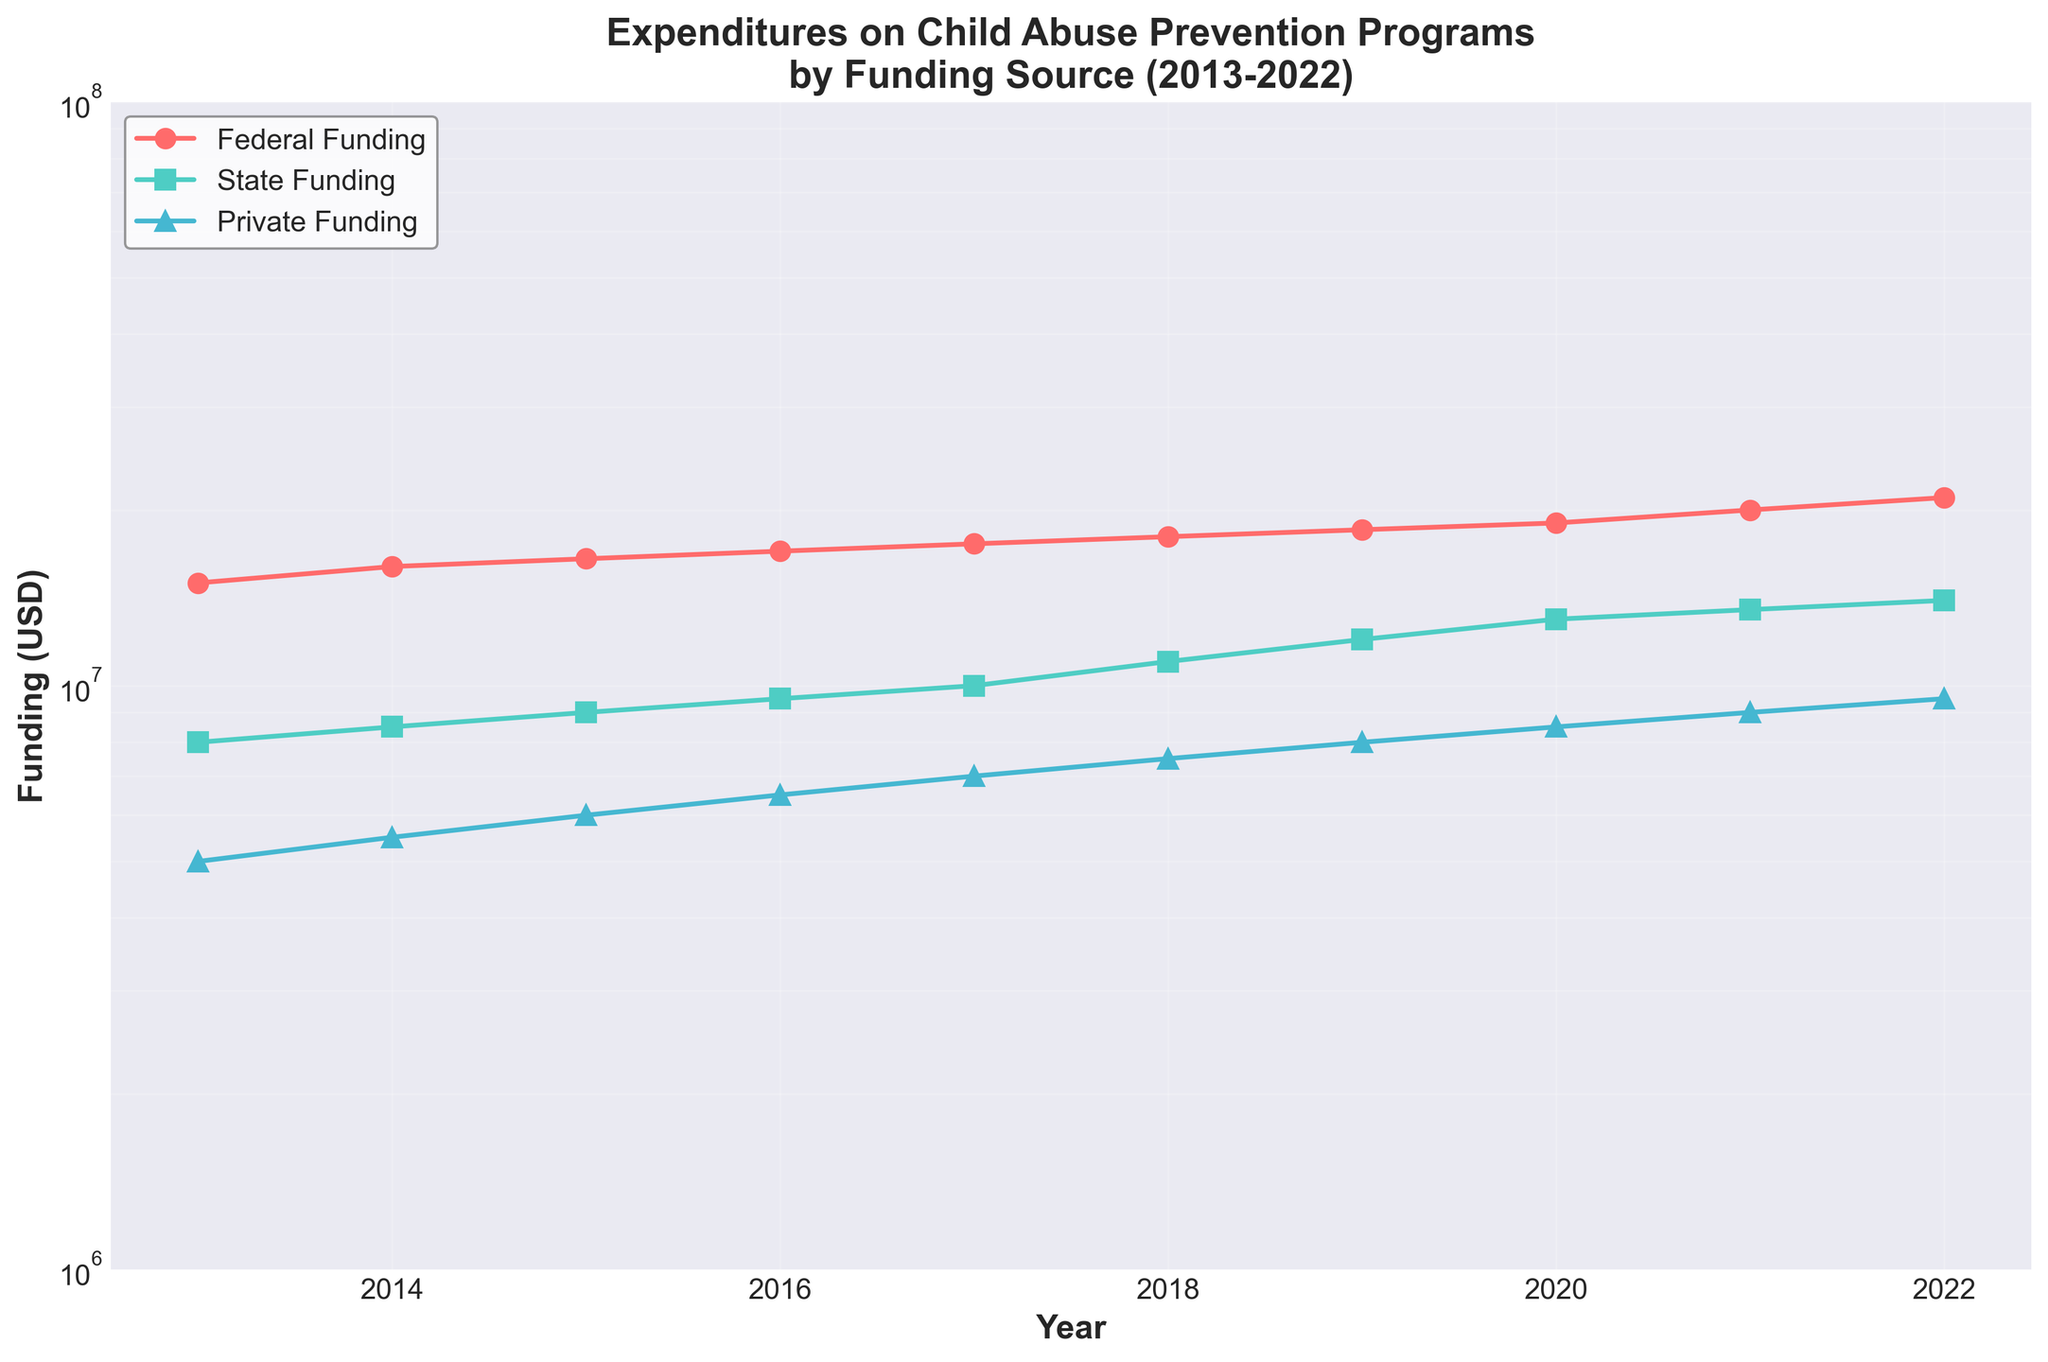What is the title of the plot? The title is typically located at the top of the plot. In this case, it is "Expenditures on Child Abuse Prevention Programs\nby Funding Source (2013-2022)"
Answer: Expenditures on Child Abuse Prevention Programs\nby Funding Source (2013-2022) What is the funding amount from federal sources in 2018? Look for the year 2018 on the x-axis, then trace vertically to the federal funding line marked with circles, and read the corresponding value on the y-axis.
Answer: 18,000,000 Which funding source had the highest expenditure in 2021? Find the year 2021 on the x-axis, then compare the values of all three funding sources (Federal, State, Private) on the y-axis for that year. The highest line in 2021 corresponds to Federal Funding.
Answer: Federal By how much did private funding increase from 2013 to 2022? Find the private funding values for 2013 and 2022, which are 5,000,000 and 9,500,000 respectively, then compute the difference: 9,500,000 - 5,000,000.
Answer: 4,500,000 What is the average federal funding over the entire period? Add the federal funding values from 2013 to 2022 and divide by the number of years (10). The computation is: (15,000,000 + 16,000,000 + 16,500,000 + 17,000,000 + 17,500,000 + 18,000,000 + 18,500,000 + 19,000,000 + 20,000,000 + 21,000,000) / 10.
Answer: 17,850,000 Between which years did state funding see the largest increase? Look at the state funding values and identify the years with the largest difference between consecutive years. The increase between 2017 (10,000,000) and 2018 (11,000,000) is the largest increase, which is 1,000,000.
Answer: 2017 to 2018 Does private funding ever exceed state funding over these years? Look at the plot lines for private and state funding and see if the private funding line (triangles) goes above the state funding line (squares) at any point. It does not.
Answer: No How many total data points are plotted for all funding sources combined? Count the number of data points for each funding source line and sum them. There are 10 years of data for each of the 3 funding sources, resulting in a total of 30 data points.
Answer: 30 